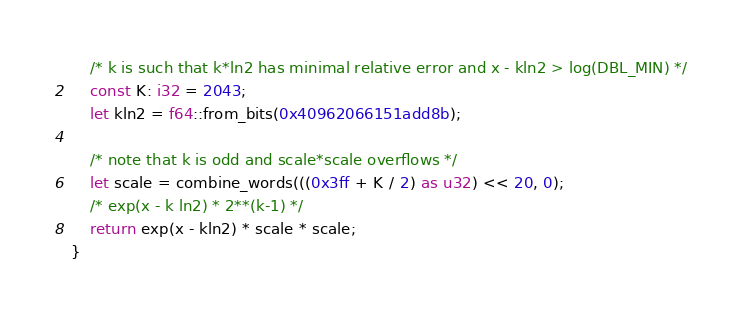<code> <loc_0><loc_0><loc_500><loc_500><_Rust_>    /* k is such that k*ln2 has minimal relative error and x - kln2 > log(DBL_MIN) */
    const K: i32 = 2043;
    let kln2 = f64::from_bits(0x40962066151add8b);

    /* note that k is odd and scale*scale overflows */
    let scale = combine_words(((0x3ff + K / 2) as u32) << 20, 0);
    /* exp(x - k ln2) * 2**(k-1) */
    return exp(x - kln2) * scale * scale;
}
</code> 